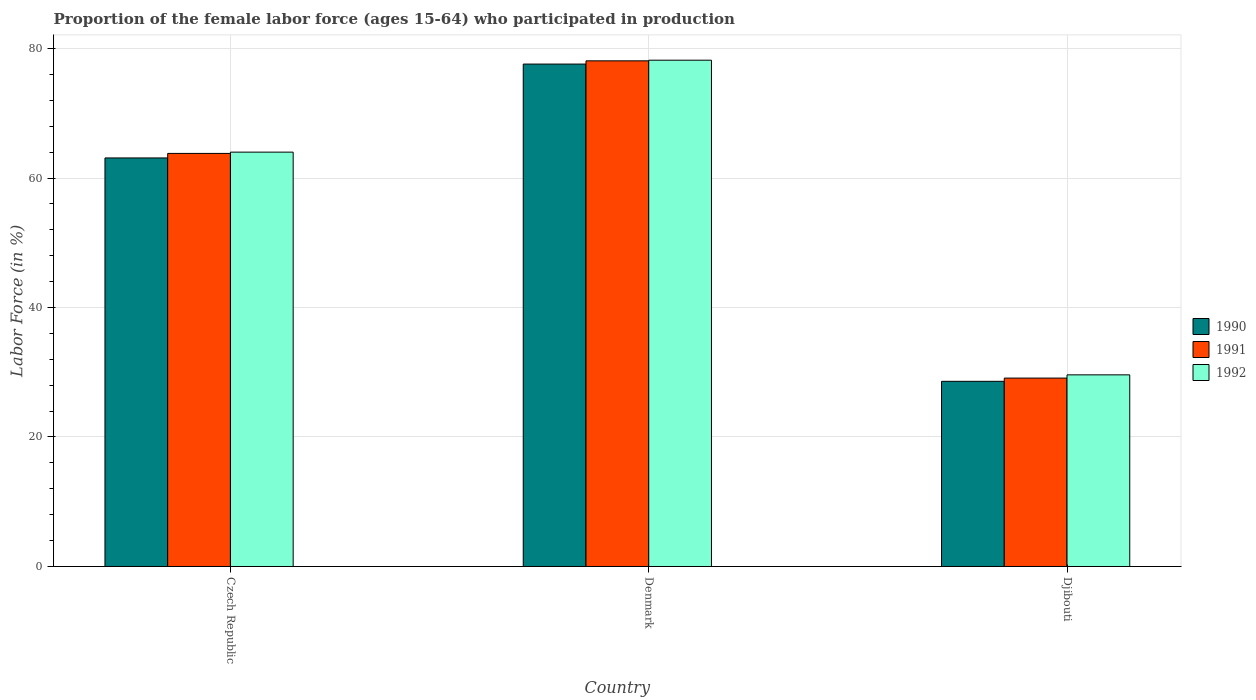Are the number of bars per tick equal to the number of legend labels?
Your answer should be compact. Yes. What is the label of the 3rd group of bars from the left?
Keep it short and to the point. Djibouti. In how many cases, is the number of bars for a given country not equal to the number of legend labels?
Your answer should be very brief. 0. What is the proportion of the female labor force who participated in production in 1992 in Czech Republic?
Provide a short and direct response. 64. Across all countries, what is the maximum proportion of the female labor force who participated in production in 1992?
Provide a succinct answer. 78.2. Across all countries, what is the minimum proportion of the female labor force who participated in production in 1992?
Your answer should be very brief. 29.6. In which country was the proportion of the female labor force who participated in production in 1992 minimum?
Make the answer very short. Djibouti. What is the total proportion of the female labor force who participated in production in 1991 in the graph?
Offer a very short reply. 171. What is the difference between the proportion of the female labor force who participated in production in 1990 in Czech Republic and that in Djibouti?
Ensure brevity in your answer.  34.5. What is the difference between the proportion of the female labor force who participated in production in 1990 in Czech Republic and the proportion of the female labor force who participated in production in 1991 in Denmark?
Ensure brevity in your answer.  -15. What is the average proportion of the female labor force who participated in production in 1991 per country?
Ensure brevity in your answer.  57. What is the ratio of the proportion of the female labor force who participated in production in 1990 in Czech Republic to that in Denmark?
Give a very brief answer. 0.81. Is the difference between the proportion of the female labor force who participated in production in 1990 in Denmark and Djibouti greater than the difference between the proportion of the female labor force who participated in production in 1991 in Denmark and Djibouti?
Keep it short and to the point. No. What is the difference between the highest and the second highest proportion of the female labor force who participated in production in 1991?
Your answer should be very brief. -49. What is the difference between the highest and the lowest proportion of the female labor force who participated in production in 1992?
Your response must be concise. 48.6. Is the sum of the proportion of the female labor force who participated in production in 1990 in Czech Republic and Denmark greater than the maximum proportion of the female labor force who participated in production in 1991 across all countries?
Keep it short and to the point. Yes. Is it the case that in every country, the sum of the proportion of the female labor force who participated in production in 1990 and proportion of the female labor force who participated in production in 1991 is greater than the proportion of the female labor force who participated in production in 1992?
Ensure brevity in your answer.  Yes. How many bars are there?
Keep it short and to the point. 9. Are the values on the major ticks of Y-axis written in scientific E-notation?
Give a very brief answer. No. Does the graph contain grids?
Keep it short and to the point. Yes. How many legend labels are there?
Keep it short and to the point. 3. What is the title of the graph?
Your answer should be very brief. Proportion of the female labor force (ages 15-64) who participated in production. Does "1976" appear as one of the legend labels in the graph?
Your response must be concise. No. What is the label or title of the Y-axis?
Make the answer very short. Labor Force (in %). What is the Labor Force (in %) in 1990 in Czech Republic?
Offer a terse response. 63.1. What is the Labor Force (in %) in 1991 in Czech Republic?
Your answer should be very brief. 63.8. What is the Labor Force (in %) in 1992 in Czech Republic?
Keep it short and to the point. 64. What is the Labor Force (in %) of 1990 in Denmark?
Your response must be concise. 77.6. What is the Labor Force (in %) of 1991 in Denmark?
Provide a short and direct response. 78.1. What is the Labor Force (in %) of 1992 in Denmark?
Provide a succinct answer. 78.2. What is the Labor Force (in %) in 1990 in Djibouti?
Keep it short and to the point. 28.6. What is the Labor Force (in %) of 1991 in Djibouti?
Offer a terse response. 29.1. What is the Labor Force (in %) of 1992 in Djibouti?
Offer a terse response. 29.6. Across all countries, what is the maximum Labor Force (in %) in 1990?
Give a very brief answer. 77.6. Across all countries, what is the maximum Labor Force (in %) in 1991?
Ensure brevity in your answer.  78.1. Across all countries, what is the maximum Labor Force (in %) of 1992?
Provide a short and direct response. 78.2. Across all countries, what is the minimum Labor Force (in %) of 1990?
Offer a terse response. 28.6. Across all countries, what is the minimum Labor Force (in %) in 1991?
Ensure brevity in your answer.  29.1. Across all countries, what is the minimum Labor Force (in %) of 1992?
Offer a very short reply. 29.6. What is the total Labor Force (in %) of 1990 in the graph?
Your response must be concise. 169.3. What is the total Labor Force (in %) in 1991 in the graph?
Make the answer very short. 171. What is the total Labor Force (in %) of 1992 in the graph?
Offer a very short reply. 171.8. What is the difference between the Labor Force (in %) in 1990 in Czech Republic and that in Denmark?
Provide a succinct answer. -14.5. What is the difference between the Labor Force (in %) in 1991 in Czech Republic and that in Denmark?
Give a very brief answer. -14.3. What is the difference between the Labor Force (in %) of 1990 in Czech Republic and that in Djibouti?
Give a very brief answer. 34.5. What is the difference between the Labor Force (in %) of 1991 in Czech Republic and that in Djibouti?
Ensure brevity in your answer.  34.7. What is the difference between the Labor Force (in %) of 1992 in Czech Republic and that in Djibouti?
Offer a terse response. 34.4. What is the difference between the Labor Force (in %) in 1992 in Denmark and that in Djibouti?
Make the answer very short. 48.6. What is the difference between the Labor Force (in %) of 1990 in Czech Republic and the Labor Force (in %) of 1992 in Denmark?
Keep it short and to the point. -15.1. What is the difference between the Labor Force (in %) in 1991 in Czech Republic and the Labor Force (in %) in 1992 in Denmark?
Provide a succinct answer. -14.4. What is the difference between the Labor Force (in %) of 1990 in Czech Republic and the Labor Force (in %) of 1992 in Djibouti?
Ensure brevity in your answer.  33.5. What is the difference between the Labor Force (in %) in 1991 in Czech Republic and the Labor Force (in %) in 1992 in Djibouti?
Your response must be concise. 34.2. What is the difference between the Labor Force (in %) in 1990 in Denmark and the Labor Force (in %) in 1991 in Djibouti?
Provide a short and direct response. 48.5. What is the difference between the Labor Force (in %) in 1991 in Denmark and the Labor Force (in %) in 1992 in Djibouti?
Give a very brief answer. 48.5. What is the average Labor Force (in %) of 1990 per country?
Your answer should be compact. 56.43. What is the average Labor Force (in %) of 1991 per country?
Your answer should be compact. 57. What is the average Labor Force (in %) of 1992 per country?
Give a very brief answer. 57.27. What is the difference between the Labor Force (in %) in 1990 and Labor Force (in %) in 1992 in Czech Republic?
Provide a short and direct response. -0.9. What is the difference between the Labor Force (in %) in 1990 and Labor Force (in %) in 1991 in Djibouti?
Ensure brevity in your answer.  -0.5. What is the difference between the Labor Force (in %) in 1990 and Labor Force (in %) in 1992 in Djibouti?
Your answer should be very brief. -1. What is the difference between the Labor Force (in %) of 1991 and Labor Force (in %) of 1992 in Djibouti?
Your answer should be very brief. -0.5. What is the ratio of the Labor Force (in %) in 1990 in Czech Republic to that in Denmark?
Provide a succinct answer. 0.81. What is the ratio of the Labor Force (in %) of 1991 in Czech Republic to that in Denmark?
Offer a very short reply. 0.82. What is the ratio of the Labor Force (in %) in 1992 in Czech Republic to that in Denmark?
Your response must be concise. 0.82. What is the ratio of the Labor Force (in %) in 1990 in Czech Republic to that in Djibouti?
Offer a terse response. 2.21. What is the ratio of the Labor Force (in %) of 1991 in Czech Republic to that in Djibouti?
Your answer should be very brief. 2.19. What is the ratio of the Labor Force (in %) of 1992 in Czech Republic to that in Djibouti?
Give a very brief answer. 2.16. What is the ratio of the Labor Force (in %) of 1990 in Denmark to that in Djibouti?
Give a very brief answer. 2.71. What is the ratio of the Labor Force (in %) of 1991 in Denmark to that in Djibouti?
Your answer should be very brief. 2.68. What is the ratio of the Labor Force (in %) in 1992 in Denmark to that in Djibouti?
Provide a short and direct response. 2.64. What is the difference between the highest and the second highest Labor Force (in %) in 1990?
Give a very brief answer. 14.5. What is the difference between the highest and the second highest Labor Force (in %) in 1991?
Provide a succinct answer. 14.3. What is the difference between the highest and the second highest Labor Force (in %) in 1992?
Your response must be concise. 14.2. What is the difference between the highest and the lowest Labor Force (in %) in 1990?
Your answer should be compact. 49. What is the difference between the highest and the lowest Labor Force (in %) of 1992?
Offer a very short reply. 48.6. 